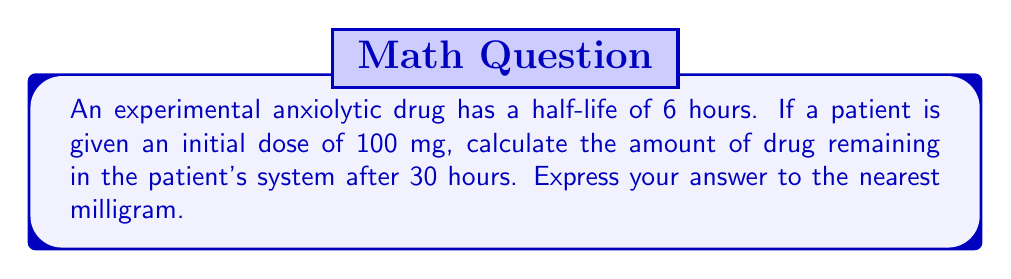Give your solution to this math problem. To solve this problem, we need to follow these steps:

1. Determine the number of half-lives that have passed:
   Time elapsed = 30 hours
   Half-life = 6 hours
   Number of half-lives = $\frac{30}{6} = 5$

2. Use the half-life decay formula:
   $A(t) = A_0 \cdot (\frac{1}{2})^n$
   Where:
   $A(t)$ is the amount remaining after time $t$
   $A_0$ is the initial amount
   $n$ is the number of half-lives

3. Plug in the values:
   $A_0 = 100$ mg
   $n = 5$

   $A(30) = 100 \cdot (\frac{1}{2})^5$

4. Calculate:
   $A(30) = 100 \cdot \frac{1}{32}$
   $A(30) = 3.125$ mg

5. Round to the nearest milligram:
   $A(30) \approx 3$ mg

Therefore, after 30 hours, approximately 3 mg of the drug remains in the patient's system.
Answer: 3 mg 